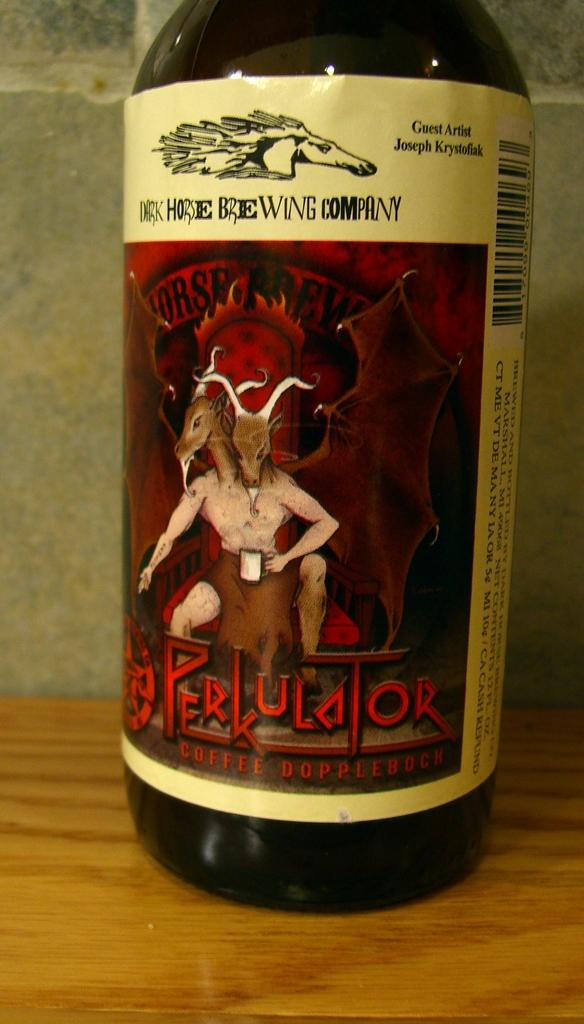<image>
Provide a brief description of the given image. a close up of a wine bottle reading Perkulator 